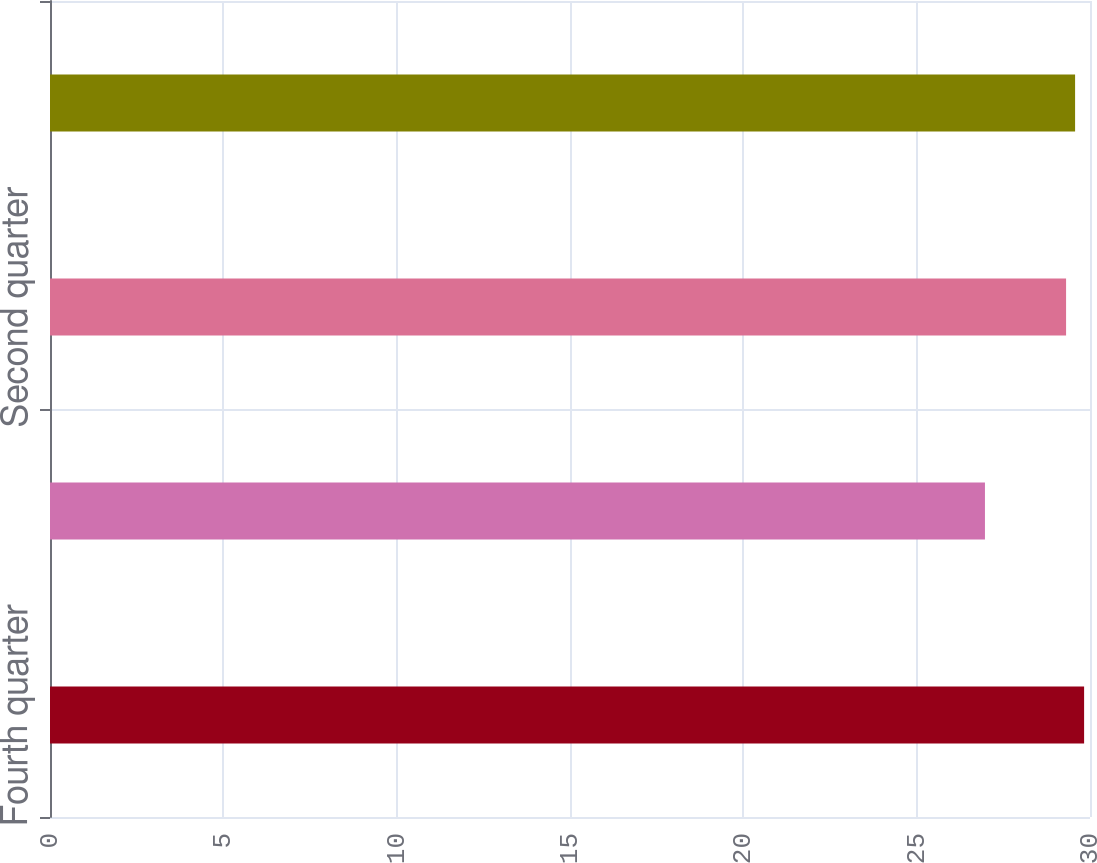Convert chart. <chart><loc_0><loc_0><loc_500><loc_500><bar_chart><fcel>Fourth quarter<fcel>Third quarter<fcel>Second quarter<fcel>First quarter<nl><fcel>29.83<fcel>26.97<fcel>29.31<fcel>29.57<nl></chart> 